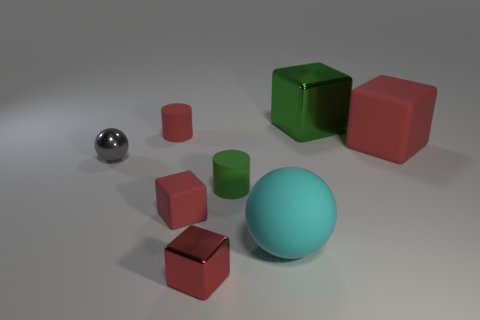How many red cubes must be subtracted to get 1 red cubes? 2 Subtract all red cubes. How many cubes are left? 1 Add 2 tiny brown metallic cylinders. How many objects exist? 10 Subtract all green cubes. How many cubes are left? 3 Subtract all cylinders. How many objects are left? 6 Subtract 1 cylinders. How many cylinders are left? 1 Add 8 large blue shiny spheres. How many large blue shiny spheres exist? 8 Subtract 0 yellow cylinders. How many objects are left? 8 Subtract all gray spheres. Subtract all purple cylinders. How many spheres are left? 1 Subtract all brown cylinders. How many red cubes are left? 3 